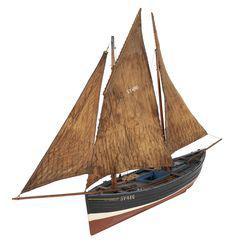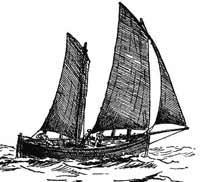The first image is the image on the left, the second image is the image on the right. Examine the images to the left and right. Is the description "One of the boats has brown sails and a red bottom." accurate? Answer yes or no. Yes. 